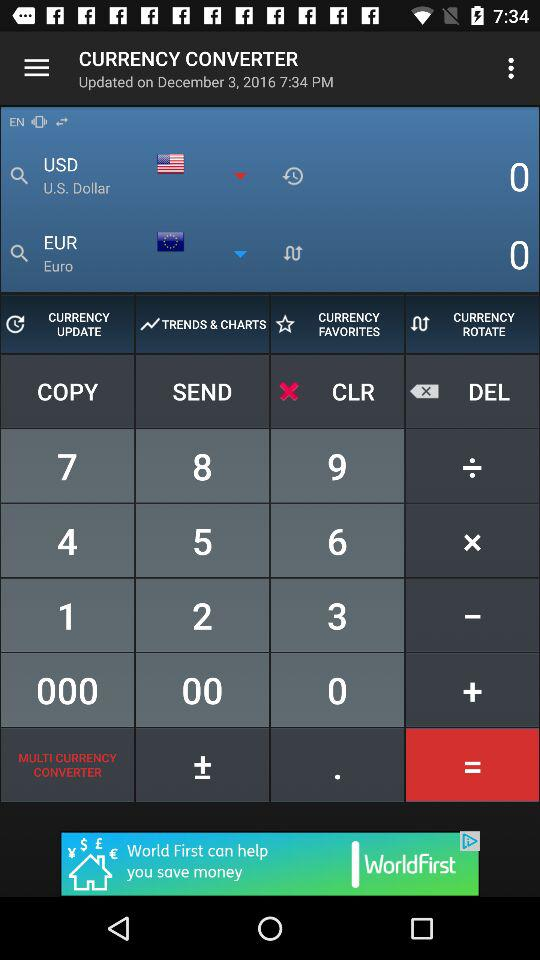Which day of the week falls on December 3, 2016?
When the provided information is insufficient, respond with <no answer>. <no answer> 